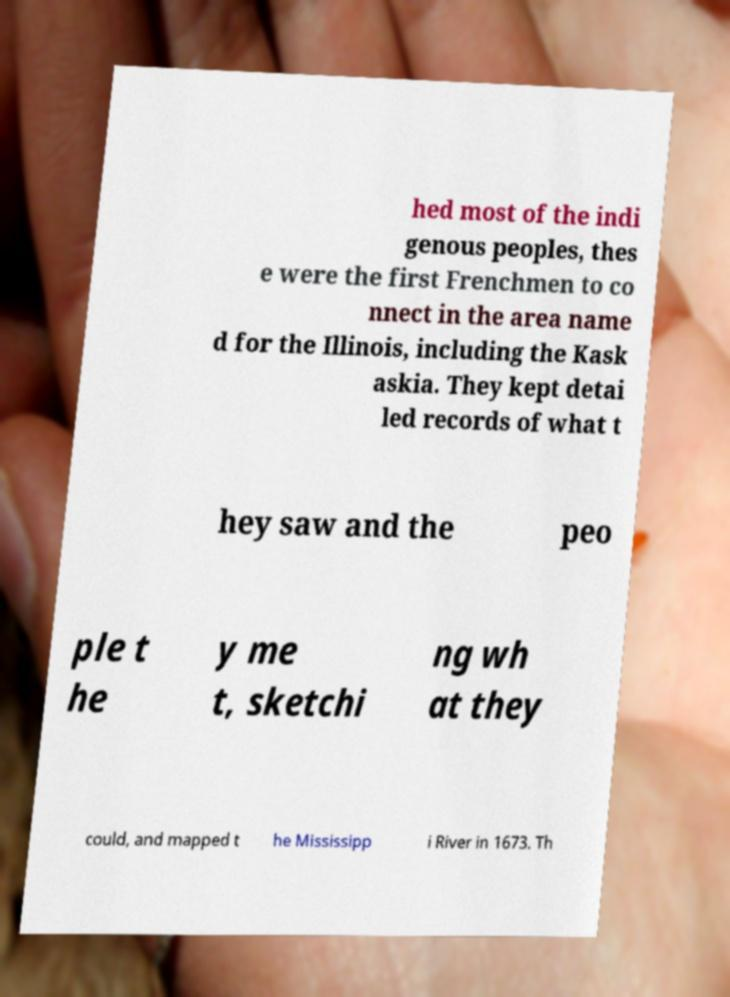There's text embedded in this image that I need extracted. Can you transcribe it verbatim? hed most of the indi genous peoples, thes e were the first Frenchmen to co nnect in the area name d for the Illinois, including the Kask askia. They kept detai led records of what t hey saw and the peo ple t he y me t, sketchi ng wh at they could, and mapped t he Mississipp i River in 1673. Th 